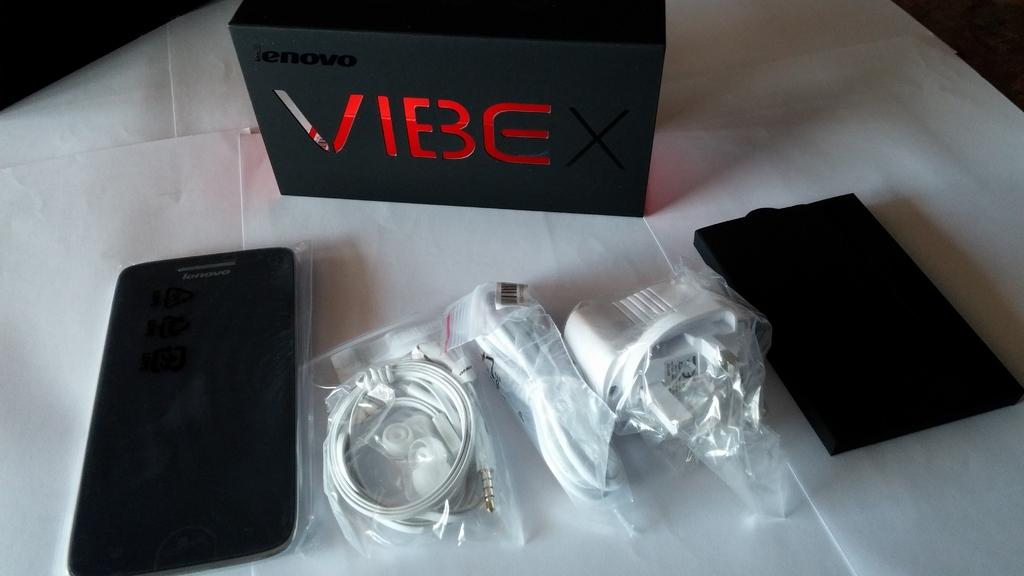Provide a one-sentence caption for the provided image. With VIBE, you get all these chargers and carrying case as well. 